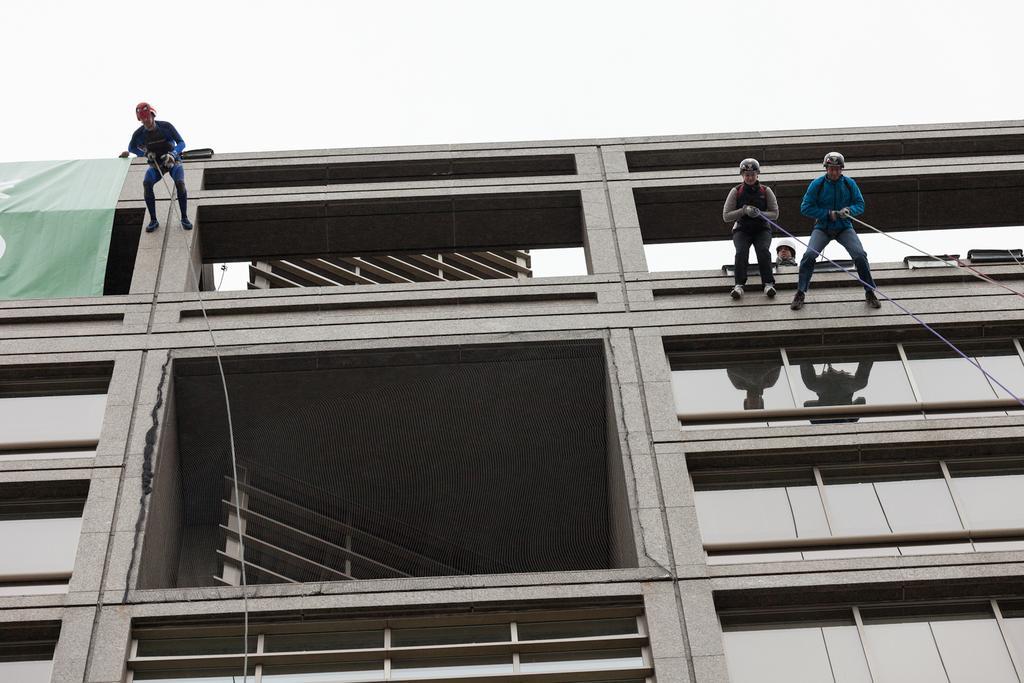Could you give a brief overview of what you see in this image? At the top of the picture we can see clear sky. This is a building. Here we can see three persons holding a rope and trying to jump from the building. Behind this two person there is one man standing. Here we can see the reflections of the persons on the glass window. 